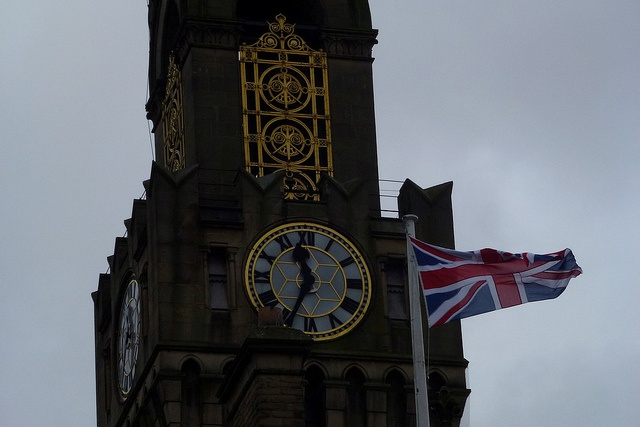Describe the objects in this image and their specific colors. I can see clock in darkgray, black, olive, and darkblue tones and clock in darkgray, black, and gray tones in this image. 